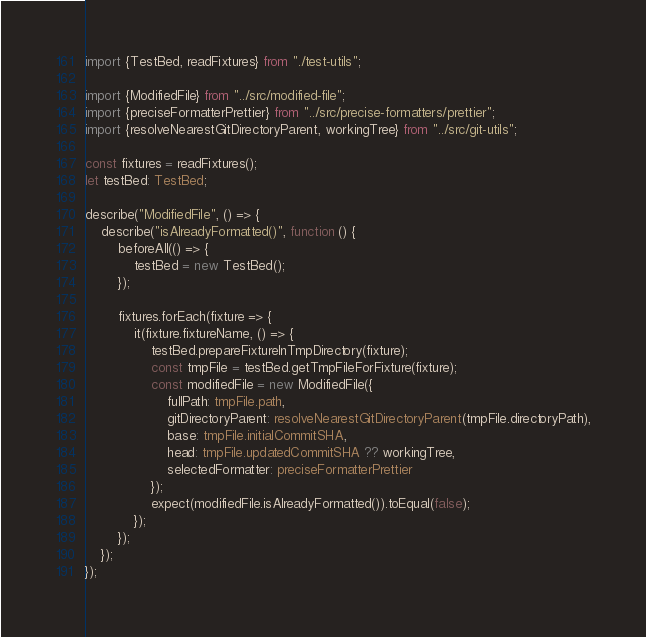<code> <loc_0><loc_0><loc_500><loc_500><_TypeScript_>import {TestBed, readFixtures} from "./test-utils";

import {ModifiedFile} from "../src/modified-file";
import {preciseFormatterPrettier} from "../src/precise-formatters/prettier";
import {resolveNearestGitDirectoryParent, workingTree} from "../src/git-utils";

const fixtures = readFixtures();
let testBed: TestBed;

describe("ModifiedFile", () => {
    describe("isAlreadyFormatted()", function () {
        beforeAll(() => {
            testBed = new TestBed();
        });

        fixtures.forEach(fixture => {
            it(fixture.fixtureName, () => {
                testBed.prepareFixtureInTmpDirectory(fixture);
                const tmpFile = testBed.getTmpFileForFixture(fixture);
                const modifiedFile = new ModifiedFile({
                    fullPath: tmpFile.path,
                    gitDirectoryParent: resolveNearestGitDirectoryParent(tmpFile.directoryPath),
                    base: tmpFile.initialCommitSHA,
                    head: tmpFile.updatedCommitSHA ?? workingTree,
                    selectedFormatter: preciseFormatterPrettier
                });
                expect(modifiedFile.isAlreadyFormatted()).toEqual(false);
            });
        });
    });
});
</code> 